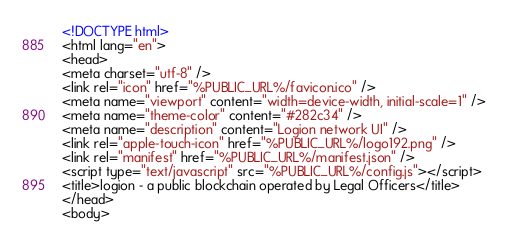Convert code to text. <code><loc_0><loc_0><loc_500><loc_500><_HTML_><!DOCTYPE html>
<html lang="en">
<head>
<meta charset="utf-8" />
<link rel="icon" href="%PUBLIC_URL%/favicon.ico" />
<meta name="viewport" content="width=device-width, initial-scale=1" />
<meta name="theme-color" content="#282c34" />
<meta name="description" content="Logion network UI" />
<link rel="apple-touch-icon" href="%PUBLIC_URL%/logo192.png" />
<link rel="manifest" href="%PUBLIC_URL%/manifest.json" />
<script type="text/javascript" src="%PUBLIC_URL%/config.js"></script>
<title>logion - a public blockchain operated by Legal Officers</title>
</head>
<body></code> 